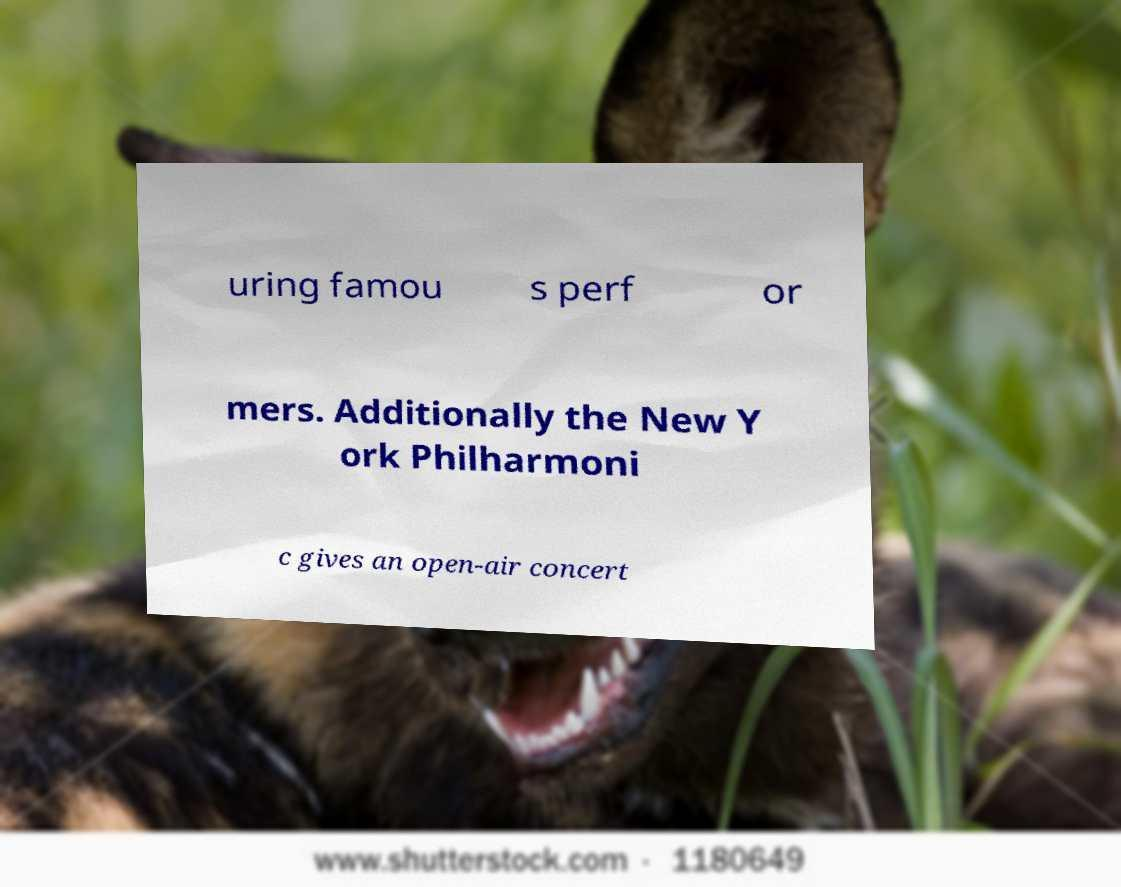Please identify and transcribe the text found in this image. uring famou s perf or mers. Additionally the New Y ork Philharmoni c gives an open-air concert 